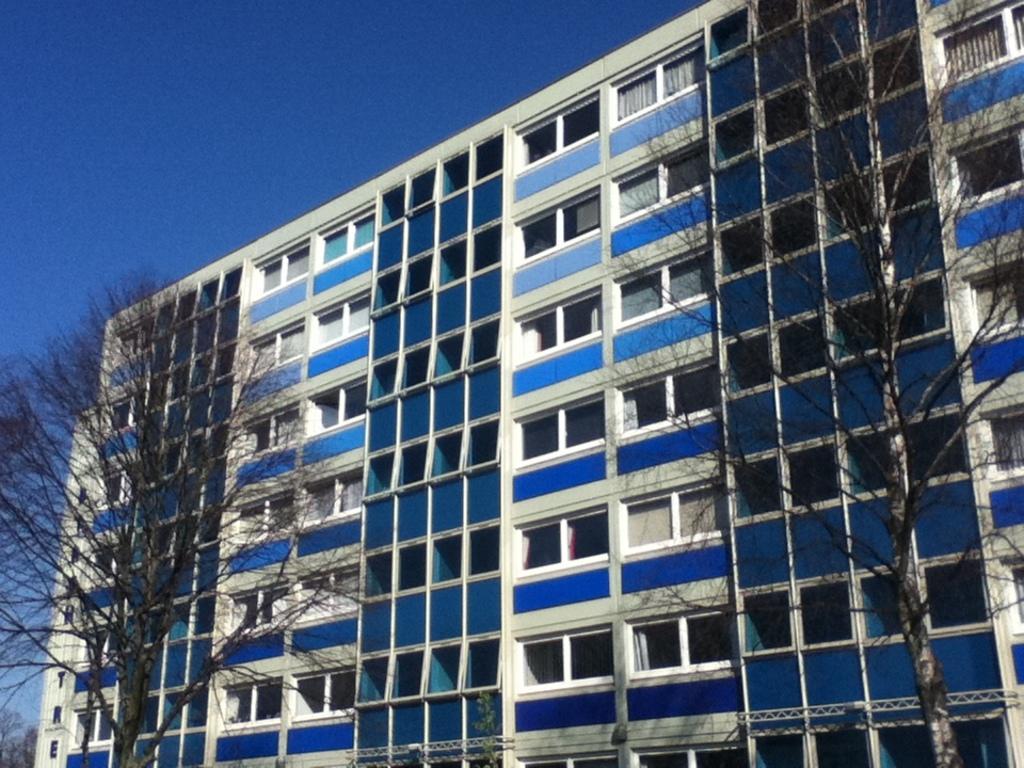Can you describe this image briefly? This picture consists of building , in front of building there are two trees and the sky visible on the left side. 